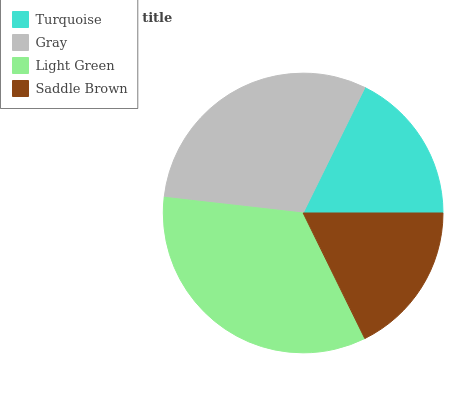Is Turquoise the minimum?
Answer yes or no. Yes. Is Light Green the maximum?
Answer yes or no. Yes. Is Gray the minimum?
Answer yes or no. No. Is Gray the maximum?
Answer yes or no. No. Is Gray greater than Turquoise?
Answer yes or no. Yes. Is Turquoise less than Gray?
Answer yes or no. Yes. Is Turquoise greater than Gray?
Answer yes or no. No. Is Gray less than Turquoise?
Answer yes or no. No. Is Gray the high median?
Answer yes or no. Yes. Is Saddle Brown the low median?
Answer yes or no. Yes. Is Saddle Brown the high median?
Answer yes or no. No. Is Turquoise the low median?
Answer yes or no. No. 